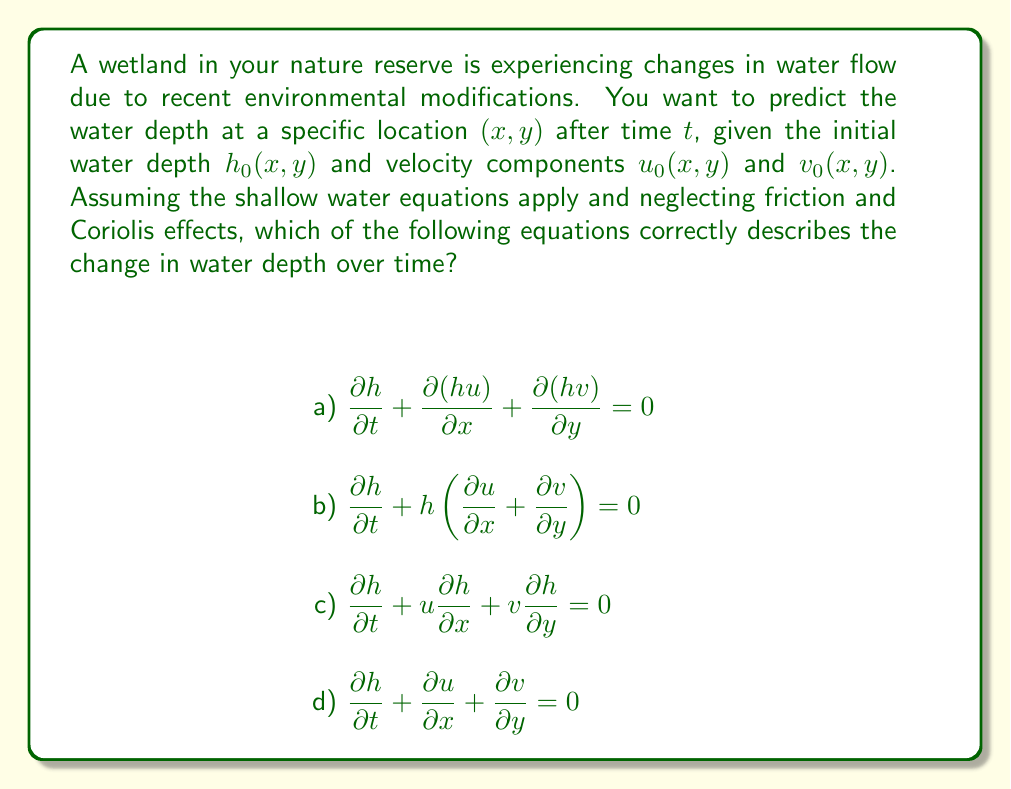What is the answer to this math problem? To predict water flow in wetland ecosystems using the shallow water equations, we need to consider the continuity equation, which describes the conservation of mass in the system. The correct form of this equation for shallow water flow is:

$$\frac{\partial h}{\partial t} + \frac{\partial(hu)}{\partial x} + \frac{\partial(hv)}{\partial y} = 0$$

Let's break down why this is the correct answer and why the other options are incorrect:

a) This is the correct equation. It represents the continuity equation for shallow water flow, where:
   - $h$ is the water depth
   - $u$ is the velocity component in the x-direction
   - $v$ is the velocity component in the y-direction
   - $\frac{\partial h}{\partial t}$ represents the change in water depth over time
   - $\frac{\partial(hu)}{\partial x}$ and $\frac{\partial(hv)}{\partial y}$ represent the net flux of water in the x and y directions, respectively

b) This equation is incorrect because it doesn't properly account for the spatial derivatives of the velocity components multiplied by the water depth.

c) This equation is the material derivative of h and doesn't properly account for the divergence of the flow field.

d) This equation is incorrect because it doesn't include the water depth $h$ in the spatial derivative terms, which is crucial for mass conservation in shallow water flow.

The correct equation (a) ensures that any change in water depth at a point is balanced by the net flux of water into or out of the surrounding area. This is essential for accurately predicting water flow and depth changes in wetland ecosystems.

For a nature reserve director, understanding this equation is crucial for predicting how changes in water flow might affect wetland habitats and for implementing sustainable water management practices.
Answer: a) $\frac{\partial h}{\partial t} + \frac{\partial(hu)}{\partial x} + \frac{\partial(hv)}{\partial y} = 0$ 